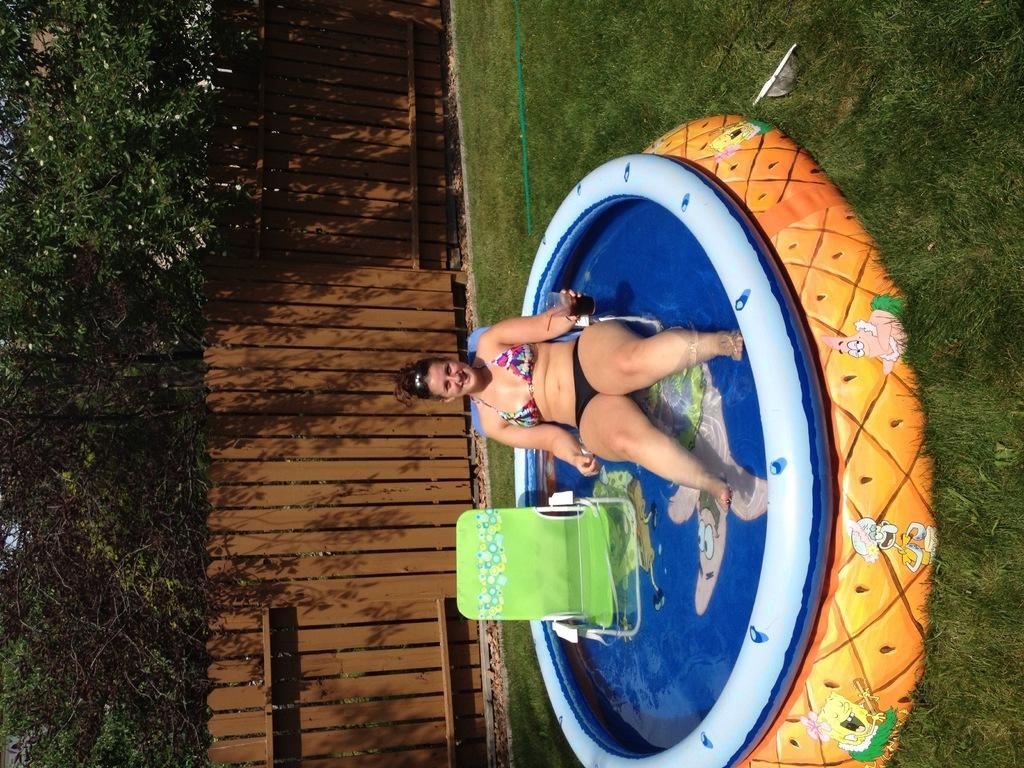Could you give a brief overview of what you see in this image? In this picture there is a woman sitting on the chair and there is water under the chairs. At the back there are trees behind the wooden railing. At the bottom there is a pipe on the grass. 